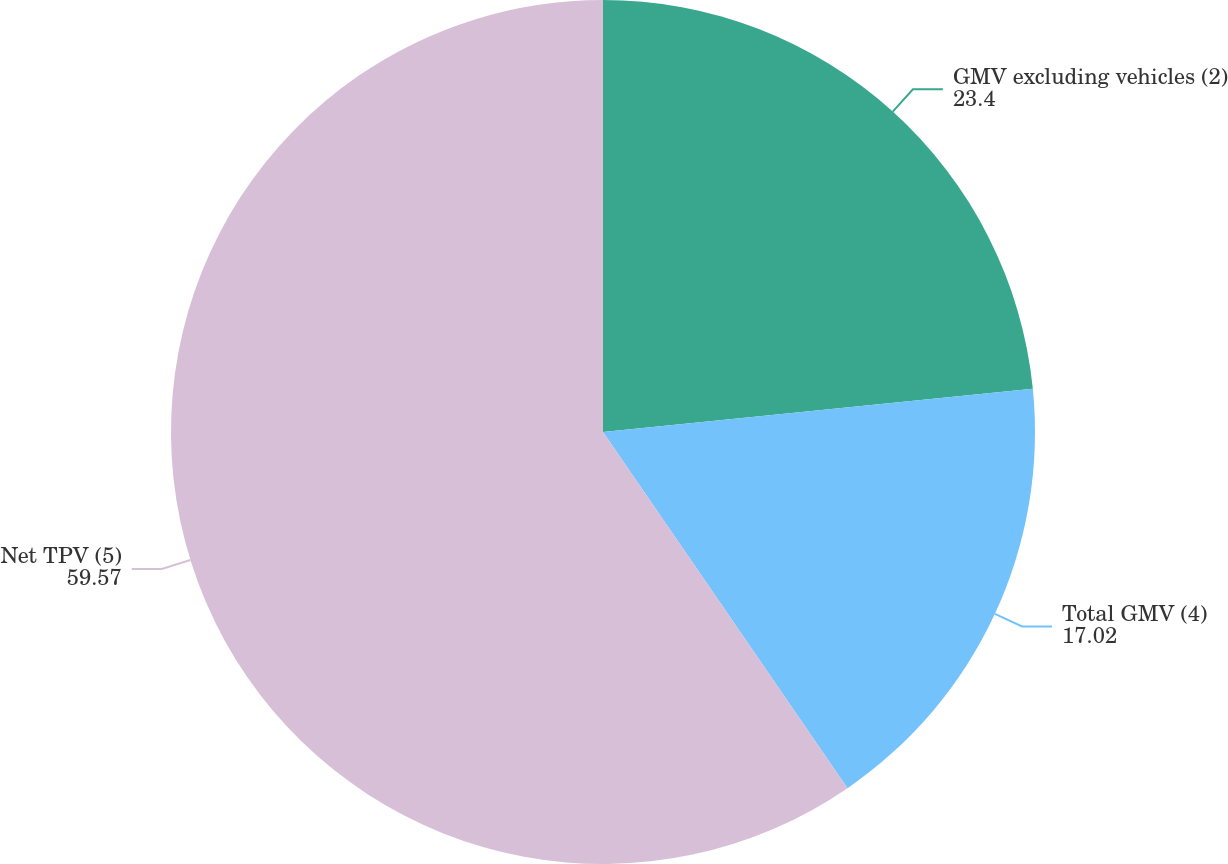Convert chart to OTSL. <chart><loc_0><loc_0><loc_500><loc_500><pie_chart><fcel>GMV excluding vehicles (2)<fcel>Total GMV (4)<fcel>Net TPV (5)<nl><fcel>23.4%<fcel>17.02%<fcel>59.57%<nl></chart> 